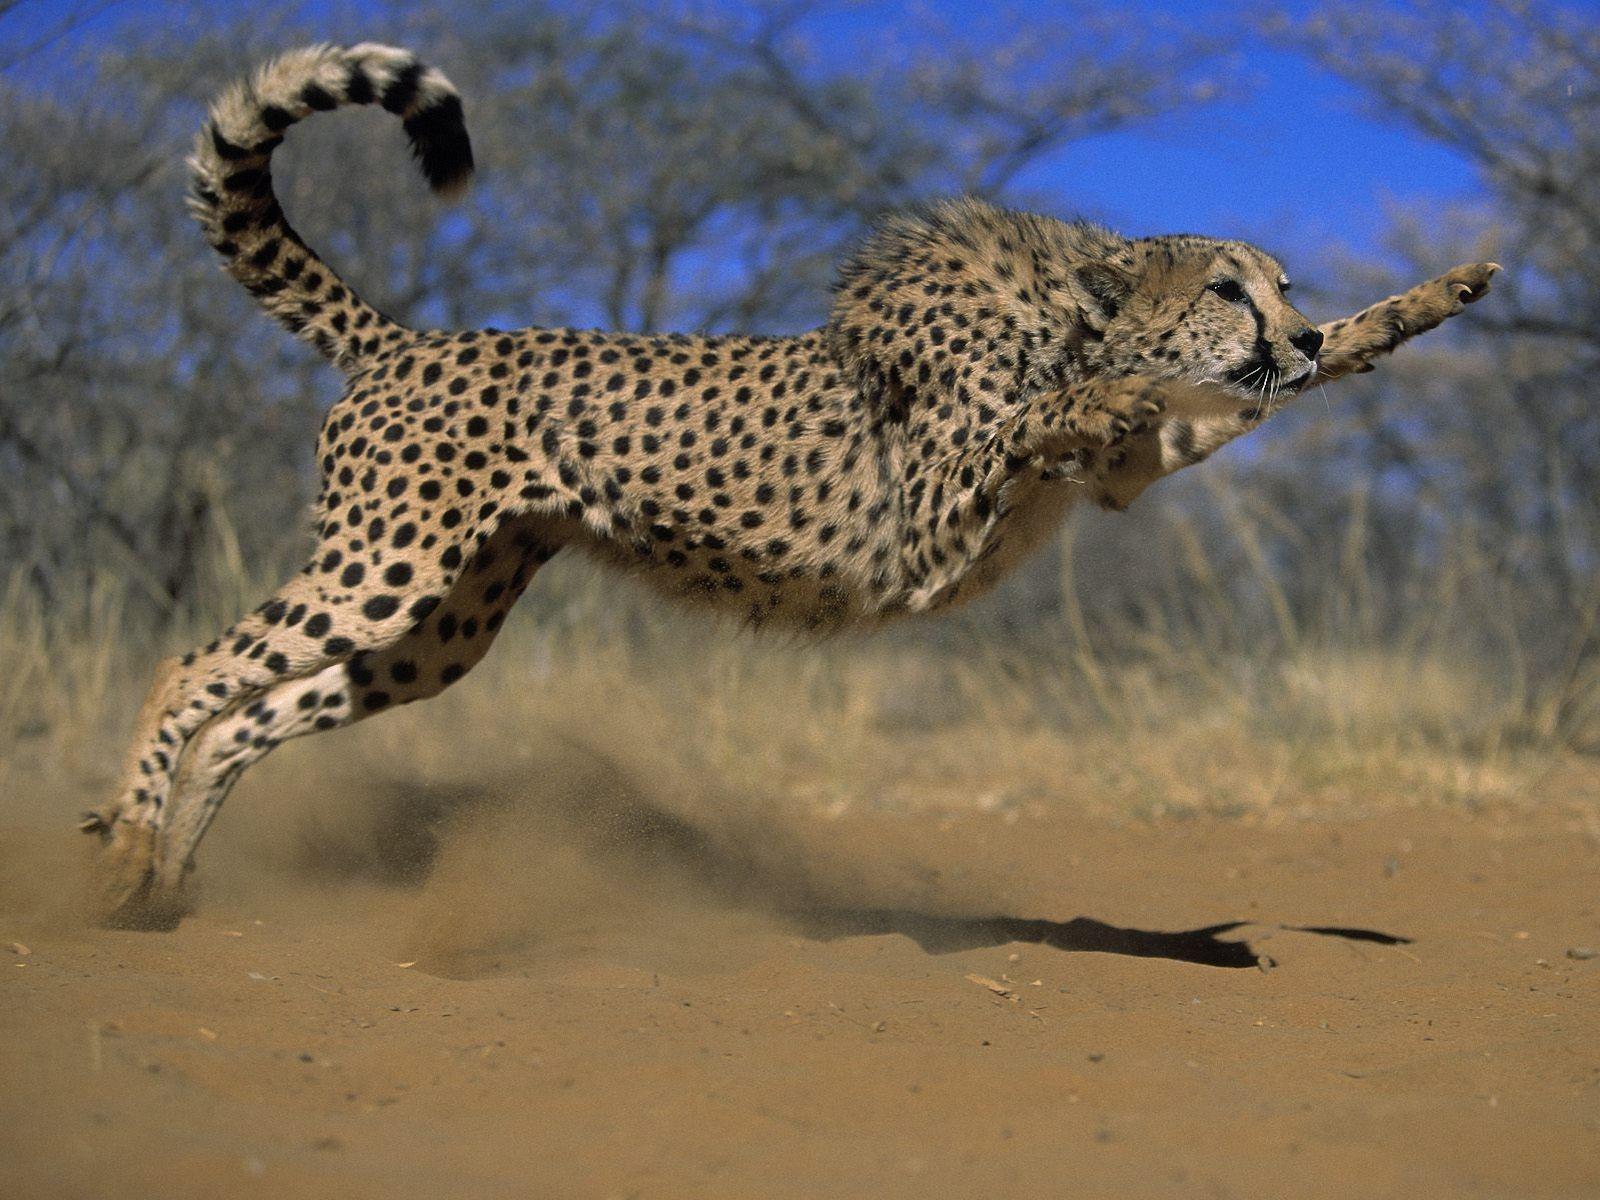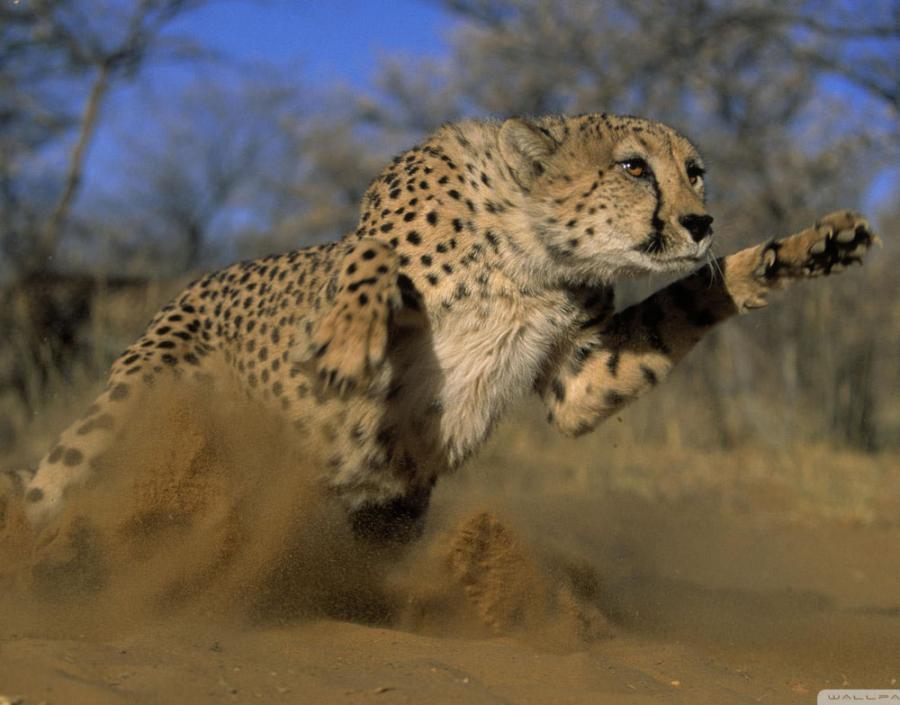The first image is the image on the left, the second image is the image on the right. Evaluate the accuracy of this statement regarding the images: "Each image contains exactly one cheetah, and each of the cheetahs depicted is in a bounding pose, with at least both front paws off the ground.". Is it true? Answer yes or no. Yes. The first image is the image on the left, the second image is the image on the right. Assess this claim about the two images: "the left and right image contains the same number of cheetahs jumping in the air.". Correct or not? Answer yes or no. Yes. 